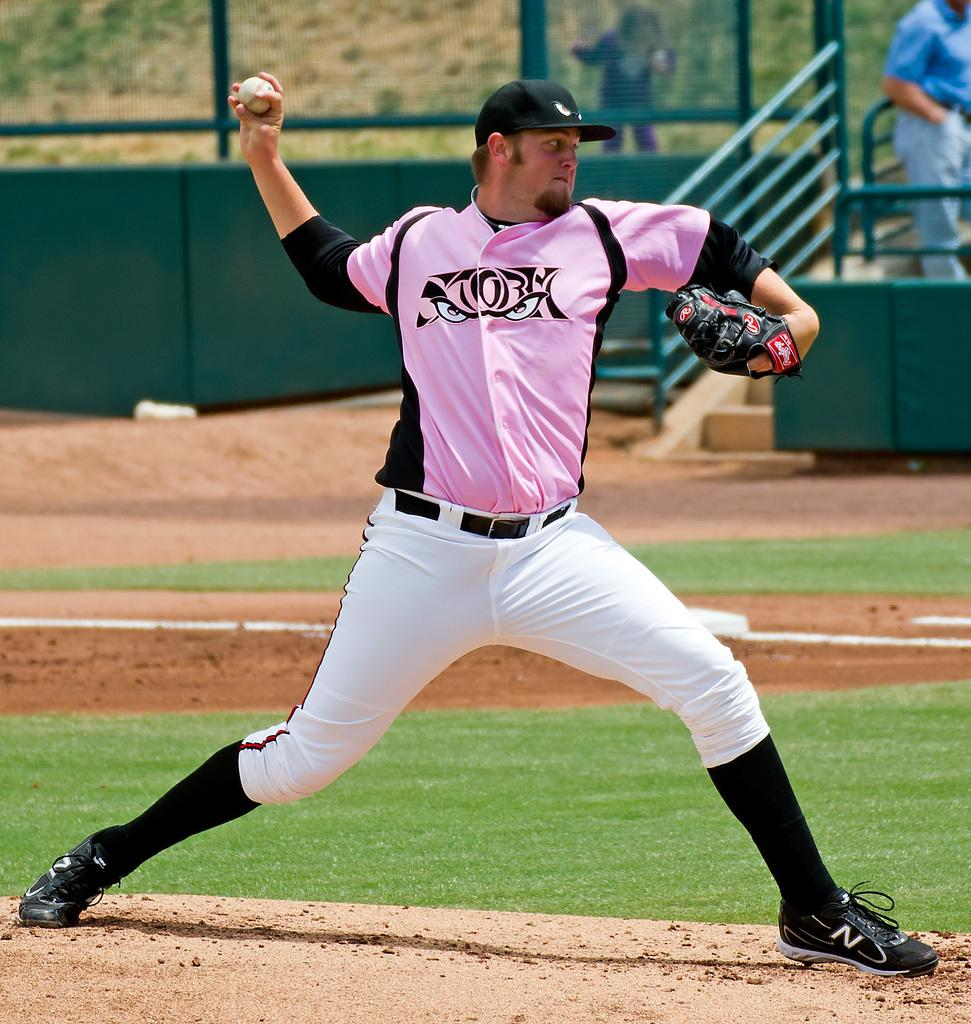<image>
Write a terse but informative summary of the picture. baseball player in a pink shirt has a mitt on his left hand branded with a R in a small red circle. 